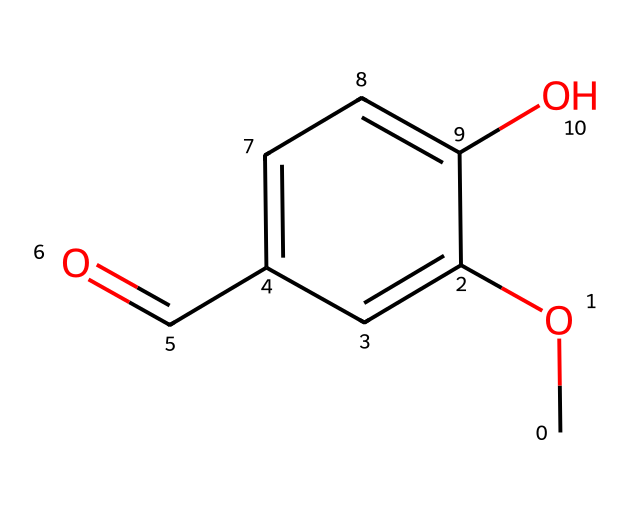What is the molecular formula of vanillin? To determine the molecular formula, count the number of each type of atom in the SMILES representation. There are 8 carbon (C), 8 hydrogen (H), and 3 oxygen (O) atoms, which gives the formula C8H8O3.
Answer: C8H8O3 How many hydroxyl (-OH) groups are present in this structure? By examining the chemical structure, identify the -OH group shown on the aromatic ring. There is one hydroxyl group attached, which is evident from the presence of the oxygen and hydrogen directly bonded to the benzene ring.
Answer: 1 What type of functional group is present in vanillin? The presence of the C=O bond (carbonyl group) along with the -O- (methoxy) and -OH (hydroxyl) groups indicates that the structure contains both an aldehyde (C=O at the end) and ether functionalities, but primarily, the aldehyde functional group defines it.
Answer: aldehyde What is the role of the methoxy (-OCH3) group in vanillin? The methoxy group is a methoxy functional group that contributes to the overall flavor and fragrance of vanillin, enhancing its aromatic properties while modifying its reactivity and solubility.
Answer: enhances aroma How does the aldehyde functionality influence vanillin's properties? The aldehyde functionality (C=O group) provides reactivity characteristic of aldehydes, making vanillin a reactive compound that can participate in various chemical reactions, like oxidation, which affects its flavor and aroma stability.
Answer: reactive Is vanillin a simple aromatic compound? Vanillin contains an aromatic ring, along with additional functional groups (aldehyde and methoxy), making it more complex than a simple aromatic compound, which would only have a benzene ring without additional features.
Answer: no 